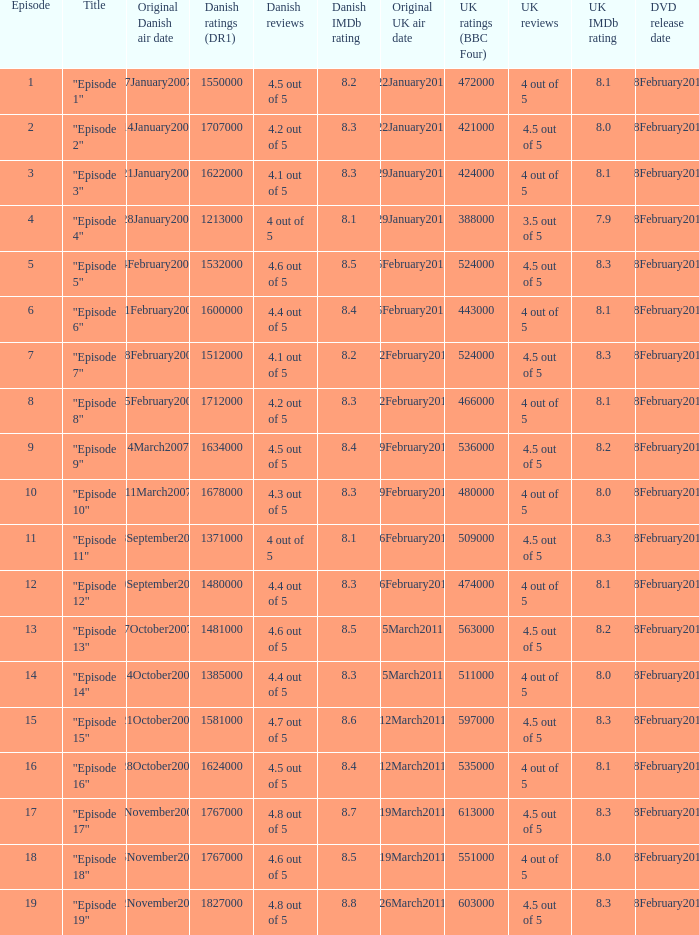What were the UK ratings (BBC Four) for "Episode 17"?  613000.0. 